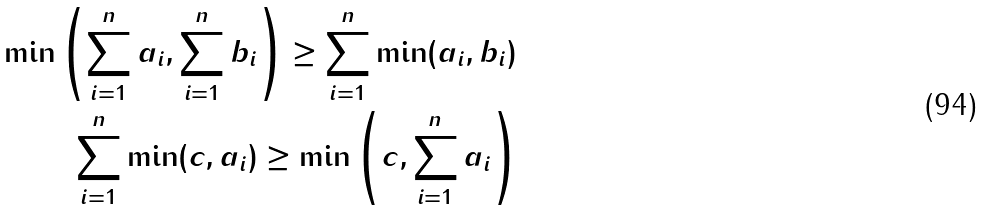<formula> <loc_0><loc_0><loc_500><loc_500>\min \left ( \sum _ { i = 1 } ^ { n } a _ { i } , \sum _ { i = 1 } ^ { n } b _ { i } \right ) \geq \sum _ { i = 1 } ^ { n } \min ( a _ { i } , b _ { i } ) \\ \sum _ { i = 1 } ^ { n } \min ( c , a _ { i } ) \geq \min \left ( c , \sum _ { i = 1 } ^ { n } a _ { i } \right )</formula> 